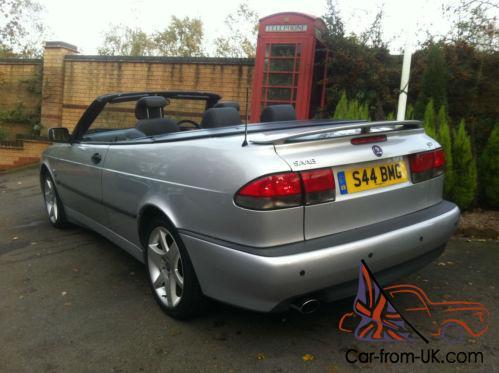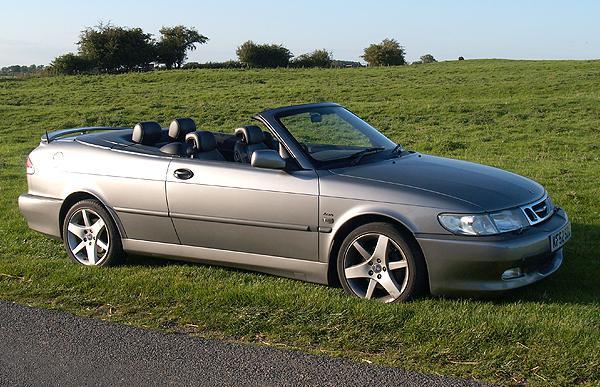The first image is the image on the left, the second image is the image on the right. Analyze the images presented: Is the assertion "The convertible in the right image has its top off." valid? Answer yes or no. Yes. The first image is the image on the left, the second image is the image on the right. Assess this claim about the two images: "Each image shows a grey convertible.". Correct or not? Answer yes or no. Yes. 